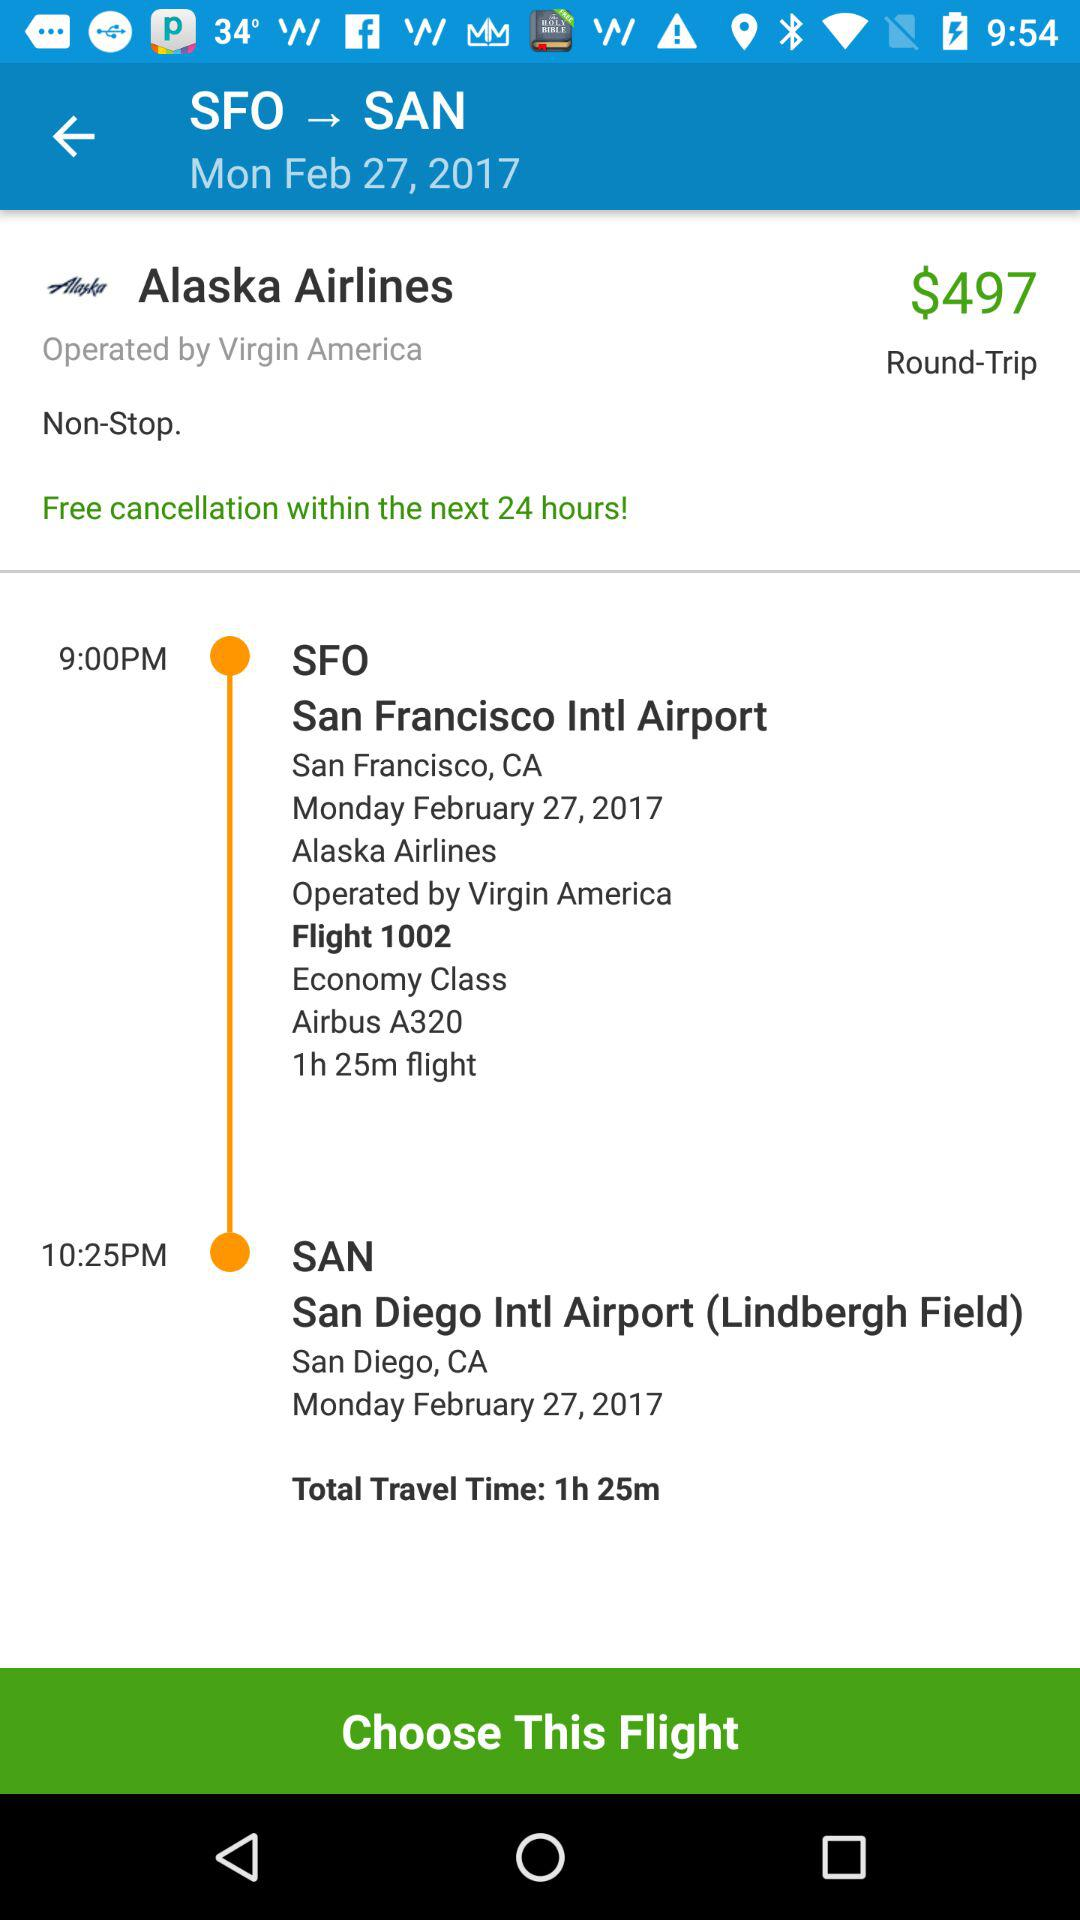What is the name of the airline? The name of the airline is "Alaska". 